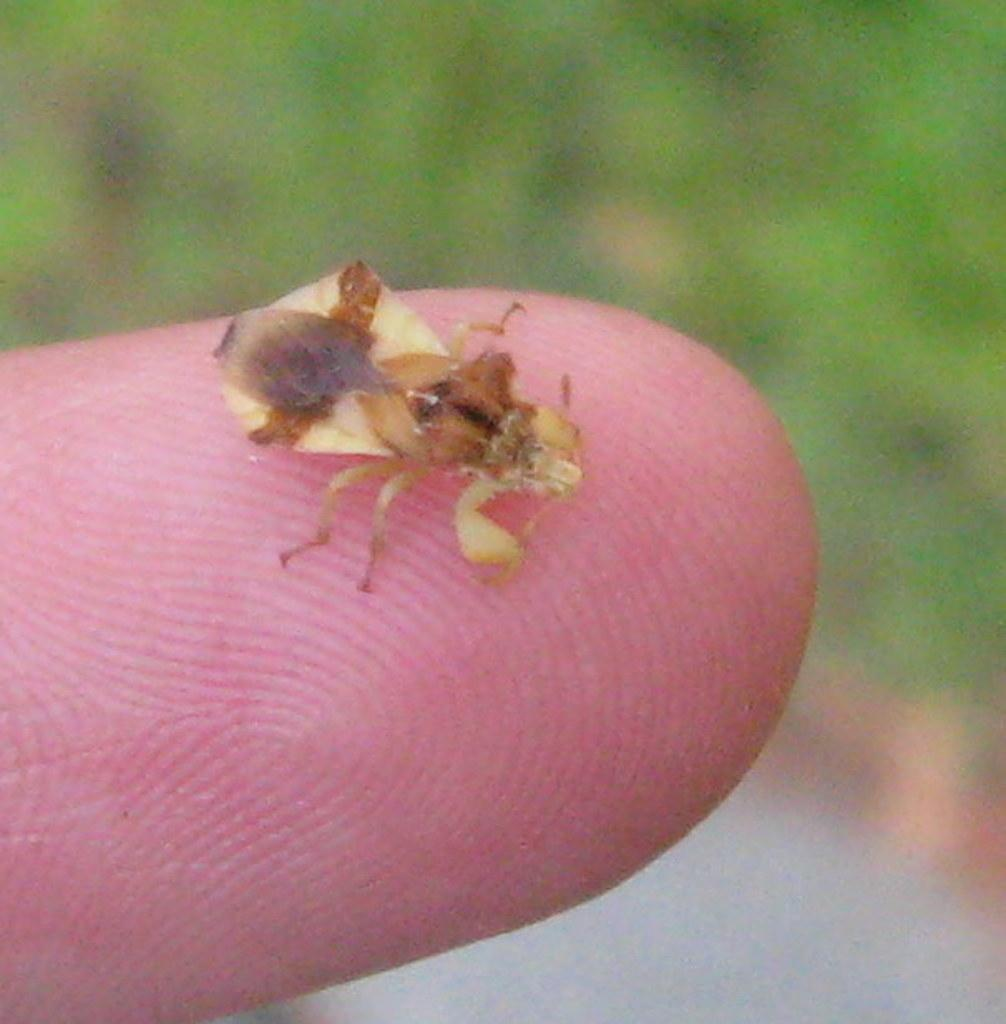What is present in the image? There is an insect in the image. Can you describe the insect's appearance? The insect is cream and brown in color. Where is the insect located in the image? The insect is on a human finger. How would you describe the background of the image? The background of the image is blurry. What type of polish is the insect applying to the human finger in the image? There is no polish present in the image, nor is the insect applying anything to the human finger. 